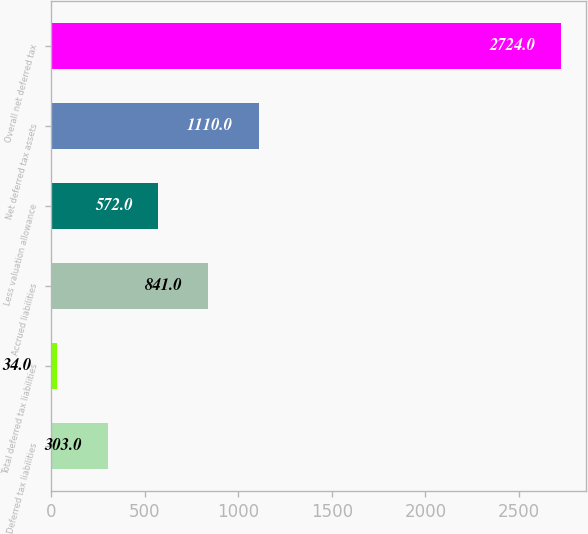Convert chart. <chart><loc_0><loc_0><loc_500><loc_500><bar_chart><fcel>Deferred tax liabilities<fcel>Total deferred tax liabilities<fcel>Accrued liabilities<fcel>Less valuation allowance<fcel>Net deferred tax assets<fcel>Overall net deferred tax<nl><fcel>303<fcel>34<fcel>841<fcel>572<fcel>1110<fcel>2724<nl></chart> 